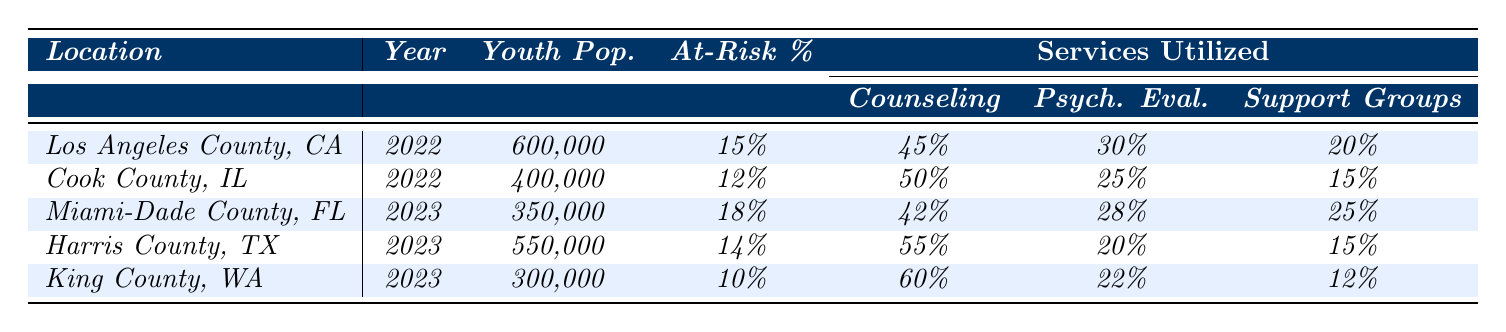What is the percentage of at-risk youth in Miami-Dade County, Florida? The table lists Miami-Dade County, Florida in 2023 with a percentage at risk of 18%.
Answer: 18% Which location has the highest percentage of youth utilizing counseling services? The table shows that King County, Washington has 60% of at-risk youth utilizing counseling services, which is higher than any other location listed.
Answer: King County, Washington How many youth are categorized as at-risk in Los Angeles County, California? Los Angeles County, California has a youth population of 600,000 and 15% of that population is at risk. Therefore, the number of at-risk youths is 600,000 * 0.15 = 90,000.
Answer: 90,000 What is the total percentage of youth receiving psychiatric evaluation and inpatient treatment in Cook County, Illinois? In Cook County, Illinois, 25% are receiving psychiatric evaluation and 10% are receiving inpatient treatment. Adding these percentages together gives 25% + 10% = 35%.
Answer: 35% Which two counties have a higher percentage of at-risk youth than Harris County, Texas? Harris County, Texas has 14% at-risk youth. By comparing percentages, Miami-Dade County (18%) and Los Angeles County (15%) have a higher percentage than Harris County.
Answer: Miami-Dade County and Los Angeles County What is the average percentage of support group utilization across all locations? Counting the percentages of support groups from each location gives: (20% + 15% + 25% + 15% + 12%) = 87%. Dividing by the number of locations (5) gives an average of 87%/5 = 17.4%.
Answer: 17.4% Is it true that Cook County, Illinois has more youth utilizing inpatient treatment than Los Angeles County, California? Los Angeles has 5% utilizing inpatient treatment, while Cook County has 10%, so the statement is true.
Answer: Yes Which location has the smallest youth population? From the table, King County, Washington has the smallest youth population listed at 300,000.
Answer: King County, Washington What is the difference in counseling service utilization between King County, Washington and Harris County, Texas? King County utilizes 60% of at-risk youth for counseling and Harris County utilizes 55%. The difference is 60% - 55% = 5%.
Answer: 5% 